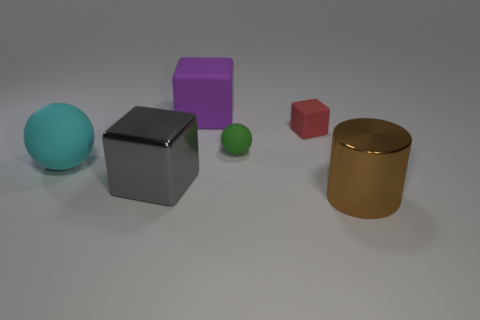Do the big rubber cube and the large sphere have the same color? No, they do not have the same color. The big rubber cube appears to be a dark grey, while the large sphere has a teal color. The lighting conditions can affect how colors are perceived, but despite this, the color difference between the cube and the sphere is quite evident. 